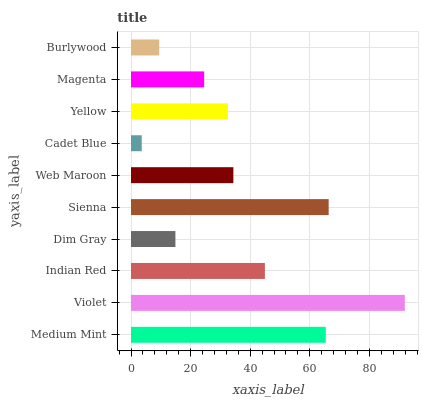Is Cadet Blue the minimum?
Answer yes or no. Yes. Is Violet the maximum?
Answer yes or no. Yes. Is Indian Red the minimum?
Answer yes or no. No. Is Indian Red the maximum?
Answer yes or no. No. Is Violet greater than Indian Red?
Answer yes or no. Yes. Is Indian Red less than Violet?
Answer yes or no. Yes. Is Indian Red greater than Violet?
Answer yes or no. No. Is Violet less than Indian Red?
Answer yes or no. No. Is Web Maroon the high median?
Answer yes or no. Yes. Is Yellow the low median?
Answer yes or no. Yes. Is Indian Red the high median?
Answer yes or no. No. Is Magenta the low median?
Answer yes or no. No. 